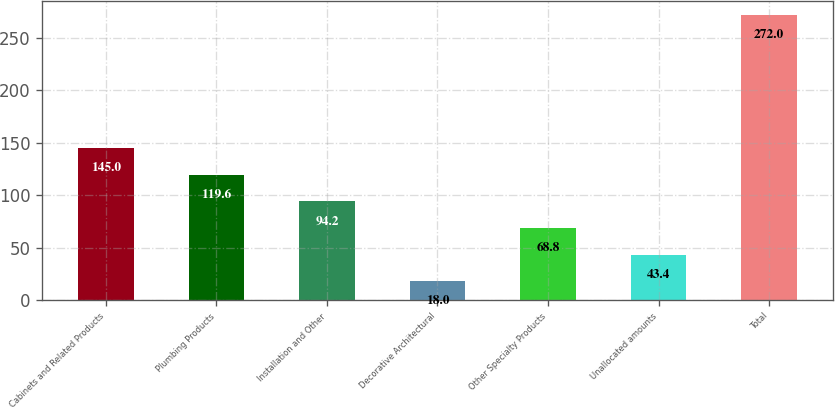Convert chart. <chart><loc_0><loc_0><loc_500><loc_500><bar_chart><fcel>Cabinets and Related Products<fcel>Plumbing Products<fcel>Installation and Other<fcel>Decorative Architectural<fcel>Other Specialty Products<fcel>Unallocated amounts<fcel>Total<nl><fcel>145<fcel>119.6<fcel>94.2<fcel>18<fcel>68.8<fcel>43.4<fcel>272<nl></chart> 